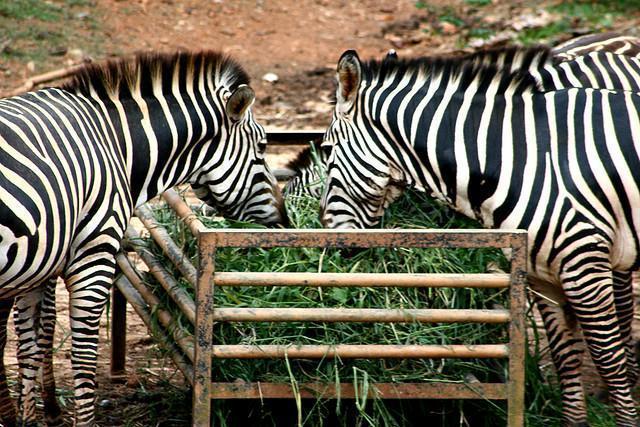How many zebras are there?
Give a very brief answer. 3. 